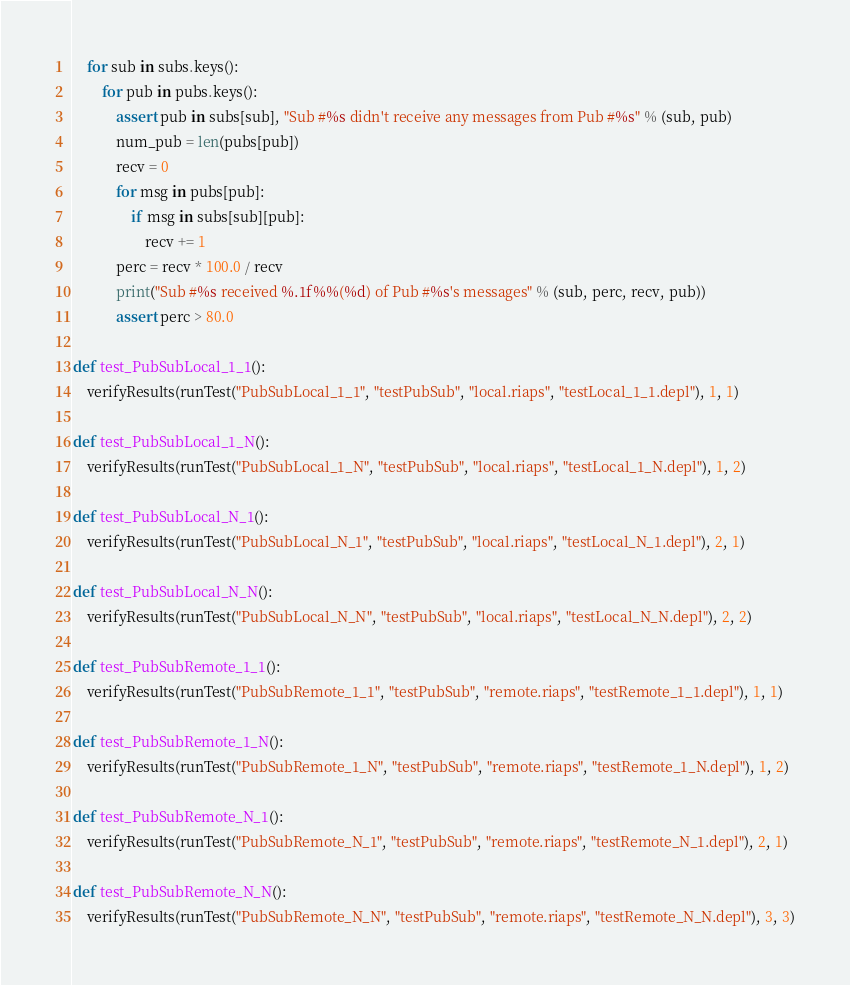Convert code to text. <code><loc_0><loc_0><loc_500><loc_500><_Python_>    for sub in subs.keys():
        for pub in pubs.keys():
            assert pub in subs[sub], "Sub #%s didn't receive any messages from Pub #%s" % (sub, pub)
            num_pub = len(pubs[pub])
            recv = 0
            for msg in pubs[pub]:
                if msg in subs[sub][pub]:
                    recv += 1
            perc = recv * 100.0 / recv
            print("Sub #%s received %.1f%%(%d) of Pub #%s's messages" % (sub, perc, recv, pub))
            assert perc > 80.0

def test_PubSubLocal_1_1():
    verifyResults(runTest("PubSubLocal_1_1", "testPubSub", "local.riaps", "testLocal_1_1.depl"), 1, 1)

def test_PubSubLocal_1_N():
    verifyResults(runTest("PubSubLocal_1_N", "testPubSub", "local.riaps", "testLocal_1_N.depl"), 1, 2)

def test_PubSubLocal_N_1():
    verifyResults(runTest("PubSubLocal_N_1", "testPubSub", "local.riaps", "testLocal_N_1.depl"), 2, 1)

def test_PubSubLocal_N_N():
    verifyResults(runTest("PubSubLocal_N_N", "testPubSub", "local.riaps", "testLocal_N_N.depl"), 2, 2)

def test_PubSubRemote_1_1():
    verifyResults(runTest("PubSubRemote_1_1", "testPubSub", "remote.riaps", "testRemote_1_1.depl"), 1, 1)

def test_PubSubRemote_1_N():
    verifyResults(runTest("PubSubRemote_1_N", "testPubSub", "remote.riaps", "testRemote_1_N.depl"), 1, 2)

def test_PubSubRemote_N_1():
    verifyResults(runTest("PubSubRemote_N_1", "testPubSub", "remote.riaps", "testRemote_N_1.depl"), 2, 1)

def test_PubSubRemote_N_N():
    verifyResults(runTest("PubSubRemote_N_N", "testPubSub", "remote.riaps", "testRemote_N_N.depl"), 3, 3)</code> 